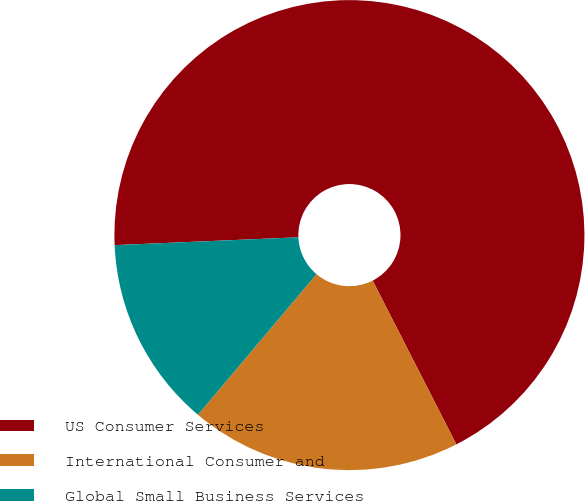Convert chart. <chart><loc_0><loc_0><loc_500><loc_500><pie_chart><fcel>US Consumer Services<fcel>International Consumer and<fcel>Global Small Business Services<nl><fcel>68.16%<fcel>18.67%<fcel>13.17%<nl></chart> 